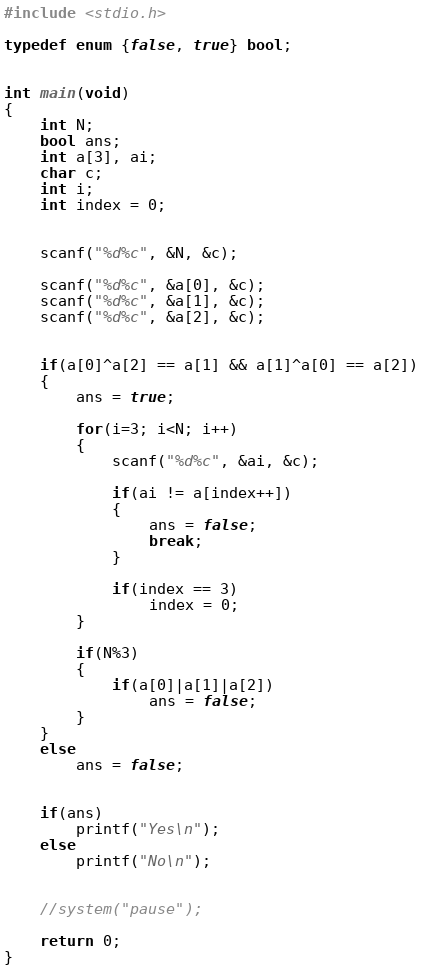Convert code to text. <code><loc_0><loc_0><loc_500><loc_500><_C_>#include <stdio.h>

typedef enum {false, true} bool;


int main(void)
{
    int N;
    bool ans;
    int a[3], ai;
    char c;
    int i;
    int index = 0;
    
    
    scanf("%d%c", &N, &c);
    
    scanf("%d%c", &a[0], &c);
    scanf("%d%c", &a[1], &c);
    scanf("%d%c", &a[2], &c);
    
    
    if(a[0]^a[2] == a[1] && a[1]^a[0] == a[2])
    {
        ans = true;
        
        for(i=3; i<N; i++)
        {
            scanf("%d%c", &ai, &c);
            
            if(ai != a[index++])
            {
                ans = false;
                break;
            }
            
            if(index == 3)
                index = 0;
        }
        
        if(N%3)
        {
            if(a[0]|a[1]|a[2])
                ans = false;
        }
    }
    else
        ans = false;
    
    
    if(ans)
        printf("Yes\n");
    else
        printf("No\n");
    
    
    //system("pause");
    
    return 0;
}
</code> 